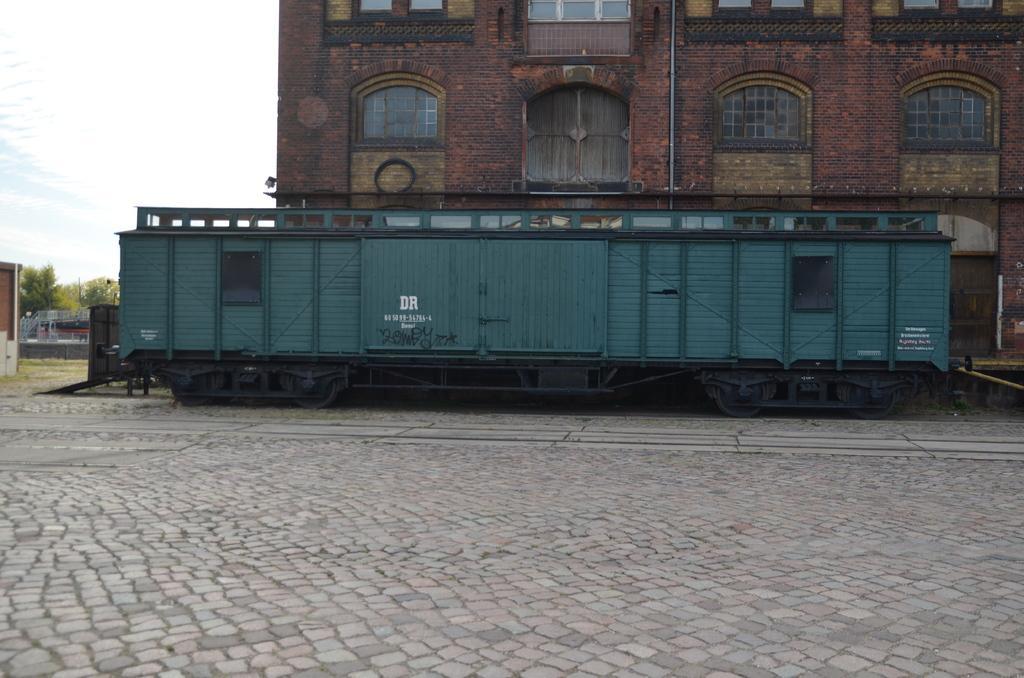Could you give a brief overview of what you see in this image? In this image there is a train wagon on the floor. In the background there is a building with the windows. On the left side there are trees in the background. At the top there is sky. 